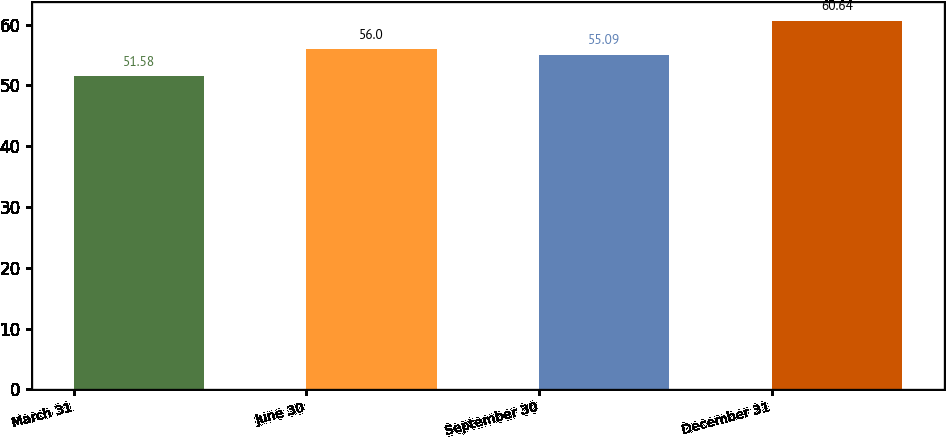<chart> <loc_0><loc_0><loc_500><loc_500><bar_chart><fcel>March 31<fcel>June 30<fcel>September 30<fcel>December 31<nl><fcel>51.58<fcel>56<fcel>55.09<fcel>60.64<nl></chart> 